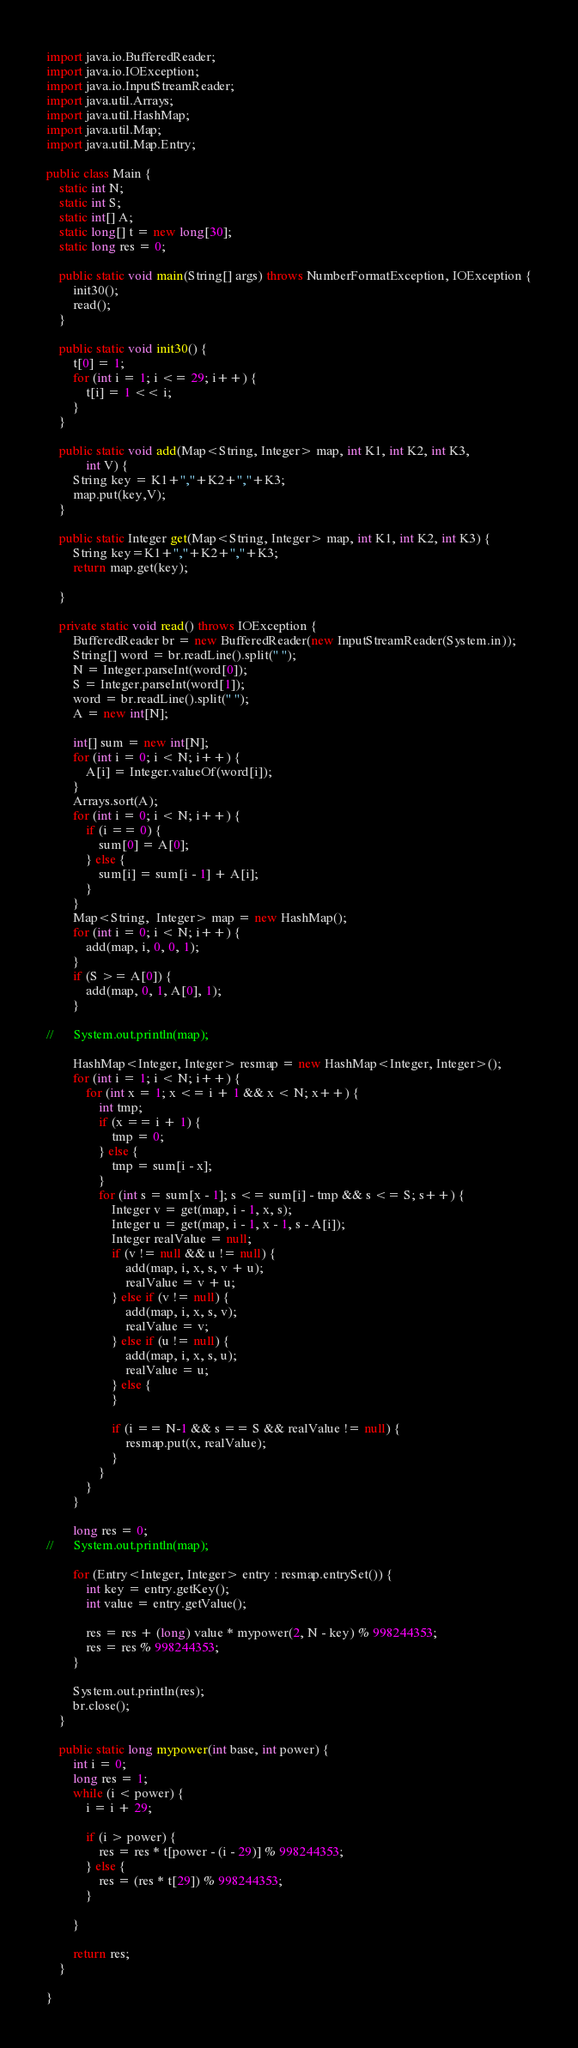Convert code to text. <code><loc_0><loc_0><loc_500><loc_500><_Java_>
import java.io.BufferedReader;
import java.io.IOException;
import java.io.InputStreamReader;
import java.util.Arrays;
import java.util.HashMap;
import java.util.Map;
import java.util.Map.Entry;

public class Main {
	static int N;
	static int S;
	static int[] A;
	static long[] t = new long[30];
	static long res = 0;

	public static void main(String[] args) throws NumberFormatException, IOException {
		init30();
		read();
	}

	public static void init30() {
		t[0] = 1;
		for (int i = 1; i <= 29; i++) {
			t[i] = 1 << i;
		}
	}

	public static void add(Map<String, Integer> map, int K1, int K2, int K3,
			int V) {
		String key = K1+","+K2+","+K3;
		map.put(key,V);
	}

	public static Integer get(Map<String, Integer> map, int K1, int K2, int K3) {
		String key=K1+","+K2+","+K3;
		return map.get(key);

	}

	private static void read() throws IOException {
		BufferedReader br = new BufferedReader(new InputStreamReader(System.in));
		String[] word = br.readLine().split(" ");
		N = Integer.parseInt(word[0]);
		S = Integer.parseInt(word[1]);
		word = br.readLine().split(" ");
		A = new int[N];

		int[] sum = new int[N];
		for (int i = 0; i < N; i++) {
			A[i] = Integer.valueOf(word[i]);
		}
		Arrays.sort(A);
		for (int i = 0; i < N; i++) {
			if (i == 0) {
				sum[0] = A[0];
			} else {
				sum[i] = sum[i - 1] + A[i];
			}
		}
		Map<String,  Integer> map = new HashMap();
		for (int i = 0; i < N; i++) {
			add(map, i, 0, 0, 1);
		}
		if (S >= A[0]) {
			add(map, 0, 1, A[0], 1);
		}

//		System.out.println(map);
		
		HashMap<Integer, Integer> resmap = new HashMap<Integer, Integer>();
		for (int i = 1; i < N; i++) {
			for (int x = 1; x <= i + 1 && x < N; x++) {
				int tmp;
				if (x == i + 1) {
					tmp = 0;
				} else {
					tmp = sum[i - x];
				}
				for (int s = sum[x - 1]; s <= sum[i] - tmp && s <= S; s++) {
					Integer v = get(map, i - 1, x, s);
					Integer u = get(map, i - 1, x - 1, s - A[i]);
					Integer realValue = null;
					if (v != null && u != null) {
						add(map, i, x, s, v + u);
						realValue = v + u;
					} else if (v != null) {
						add(map, i, x, s, v);
						realValue = v;
					} else if (u != null) {
						add(map, i, x, s, u);
						realValue = u;
					} else {
					}

					if (i == N-1 && s == S && realValue != null) {
						resmap.put(x, realValue);
					}
				}
			}
		}

		long res = 0;
//		System.out.println(map);

		for (Entry<Integer, Integer> entry : resmap.entrySet()) {
			int key = entry.getKey();
			int value = entry.getValue();

			res = res + (long) value * mypower(2, N - key) % 998244353;
			res = res % 998244353;
		}

		System.out.println(res);
		br.close();
	}

	public static long mypower(int base, int power) {
		int i = 0;
		long res = 1;
		while (i < power) {
			i = i + 29;

			if (i > power) {
				res = res * t[power - (i - 29)] % 998244353;
			} else {
				res = (res * t[29]) % 998244353;
			}

		}

		return res;
	}

}
</code> 